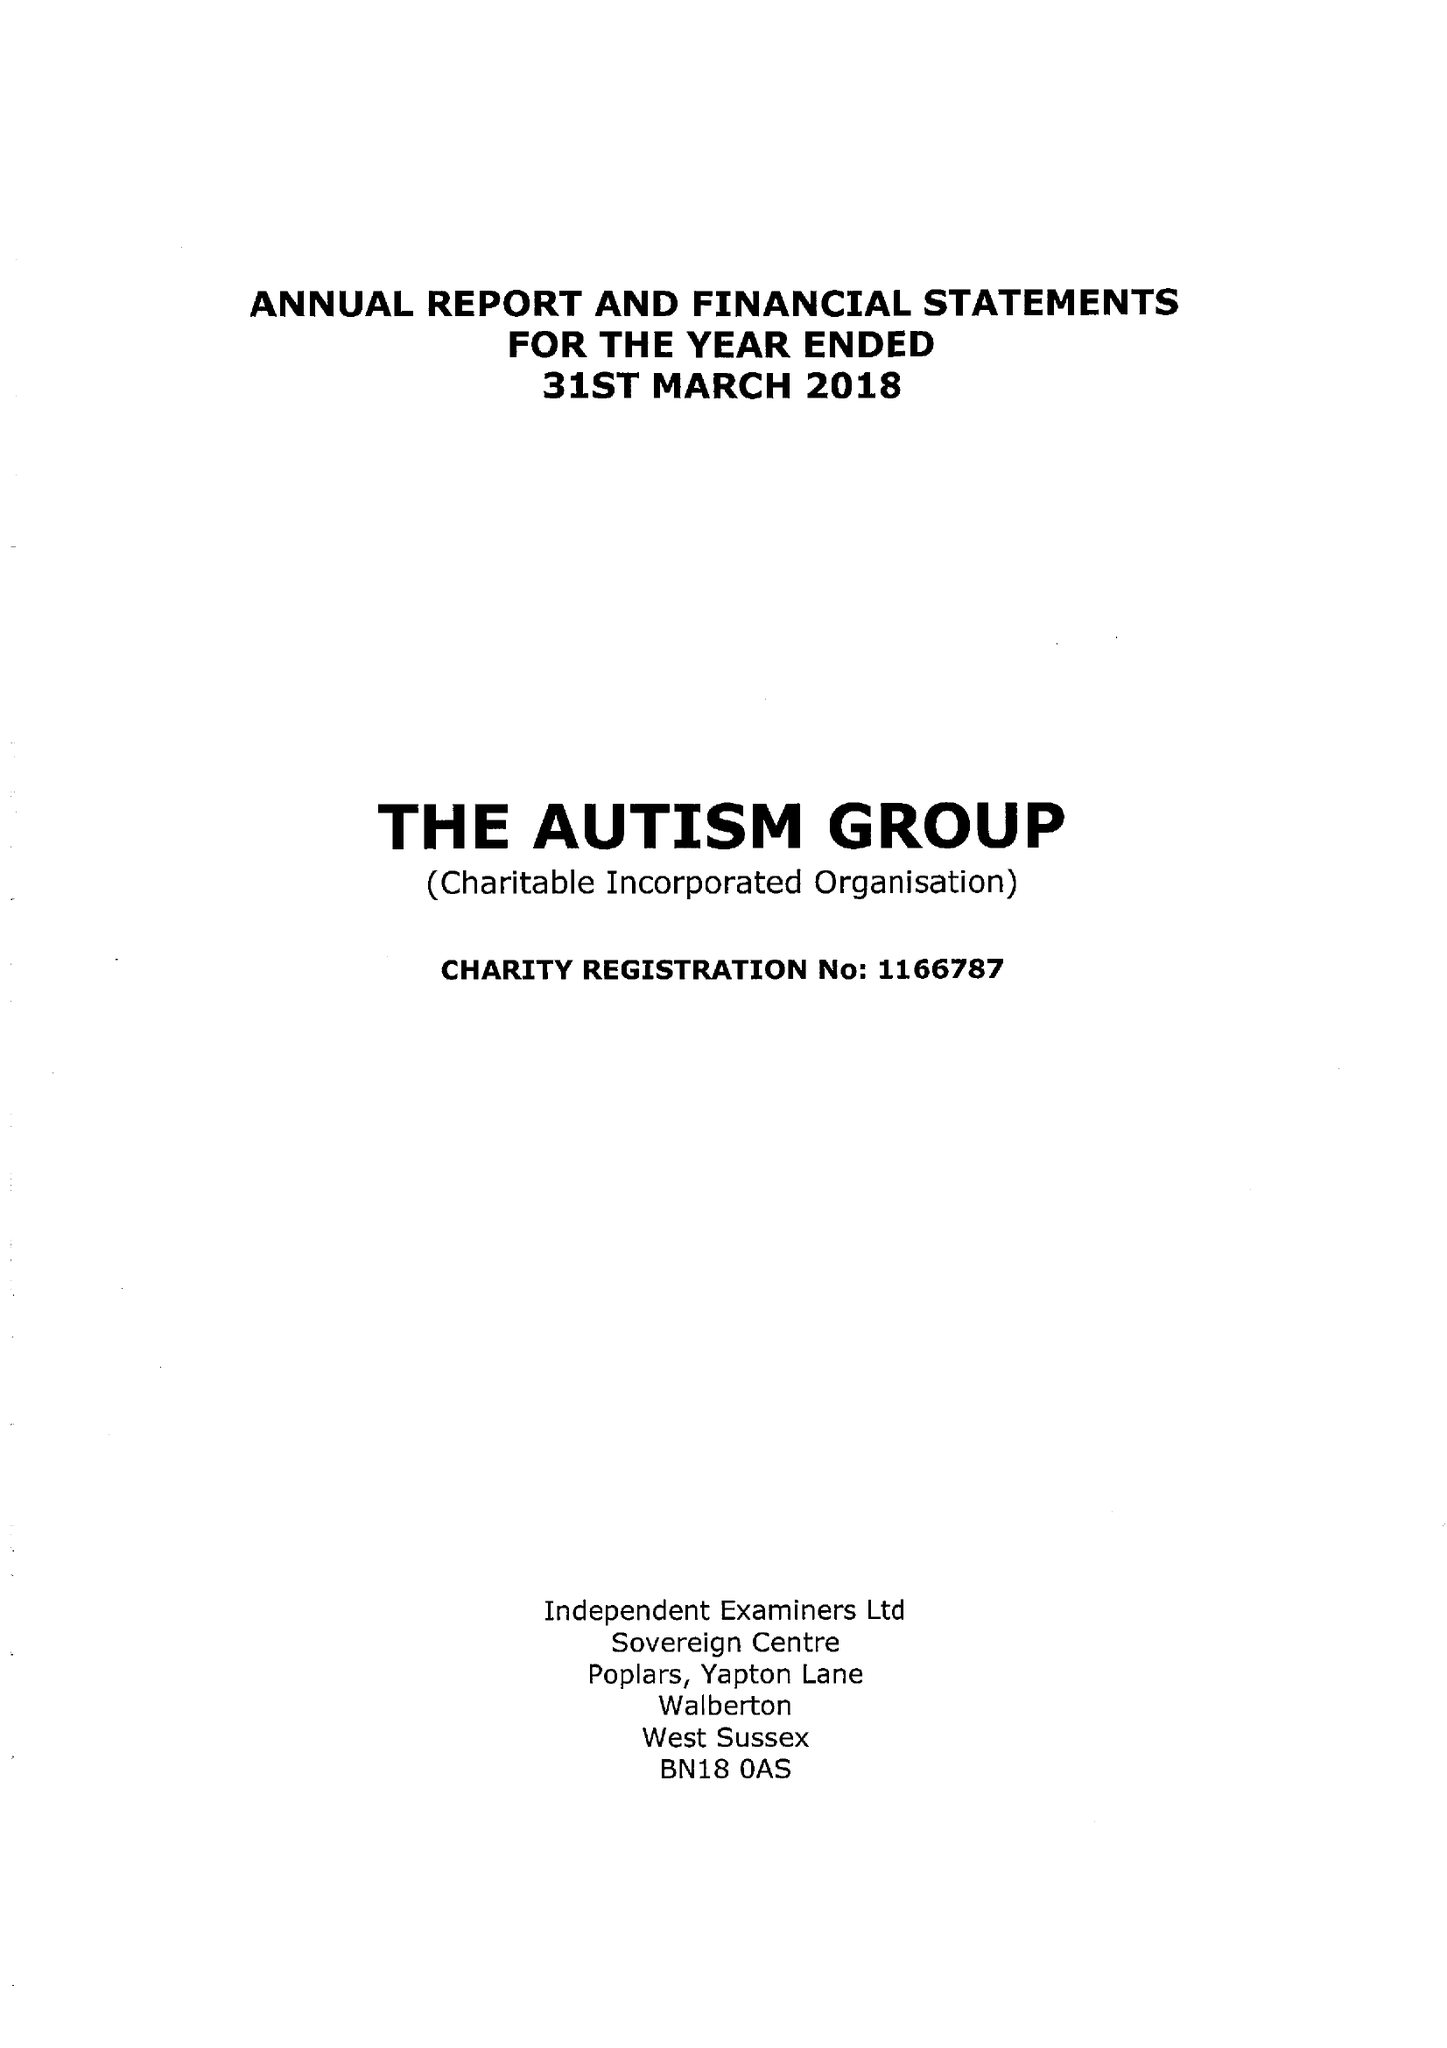What is the value for the address__street_line?
Answer the question using a single word or phrase. 29 BROADWAY 